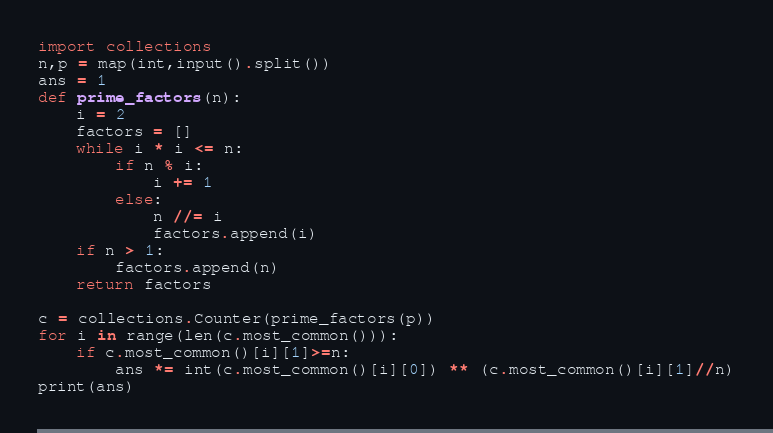<code> <loc_0><loc_0><loc_500><loc_500><_Python_>import collections
n,p = map(int,input().split())
ans = 1
def prime_factors(n):
    i = 2
    factors = []
    while i * i <= n:
        if n % i:
            i += 1
        else:
            n //= i
            factors.append(i)
    if n > 1:
        factors.append(n)
    return factors

c = collections.Counter(prime_factors(p))
for i in range(len(c.most_common())):
    if c.most_common()[i][1]>=n:
        ans *= int(c.most_common()[i][0]) ** (c.most_common()[i][1]//n)
print(ans)</code> 